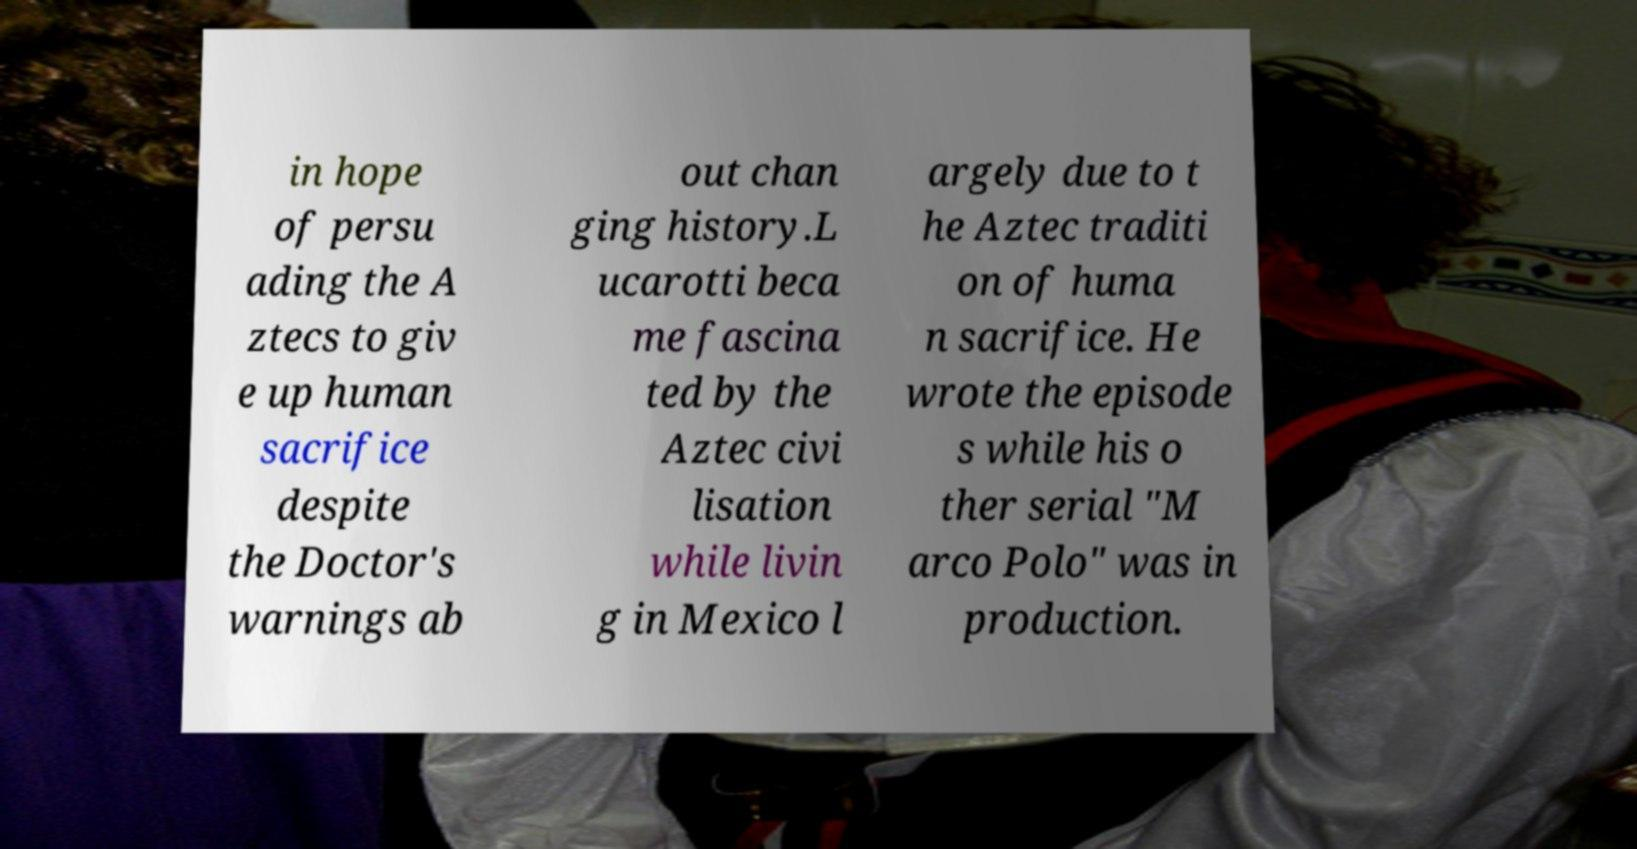Can you read and provide the text displayed in the image?This photo seems to have some interesting text. Can you extract and type it out for me? in hope of persu ading the A ztecs to giv e up human sacrifice despite the Doctor's warnings ab out chan ging history.L ucarotti beca me fascina ted by the Aztec civi lisation while livin g in Mexico l argely due to t he Aztec traditi on of huma n sacrifice. He wrote the episode s while his o ther serial "M arco Polo" was in production. 